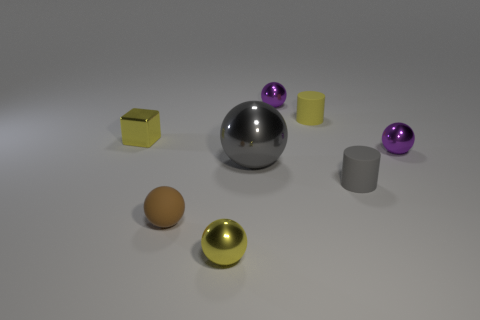Subtract all tiny rubber balls. How many balls are left? 4 Subtract all cyan spheres. Subtract all yellow cylinders. How many spheres are left? 5 Add 1 small yellow metallic objects. How many objects exist? 9 Subtract all cubes. How many objects are left? 7 Add 1 tiny objects. How many tiny objects exist? 8 Subtract 0 cyan cubes. How many objects are left? 8 Subtract all gray shiny spheres. Subtract all tiny gray matte cylinders. How many objects are left? 6 Add 7 cylinders. How many cylinders are left? 9 